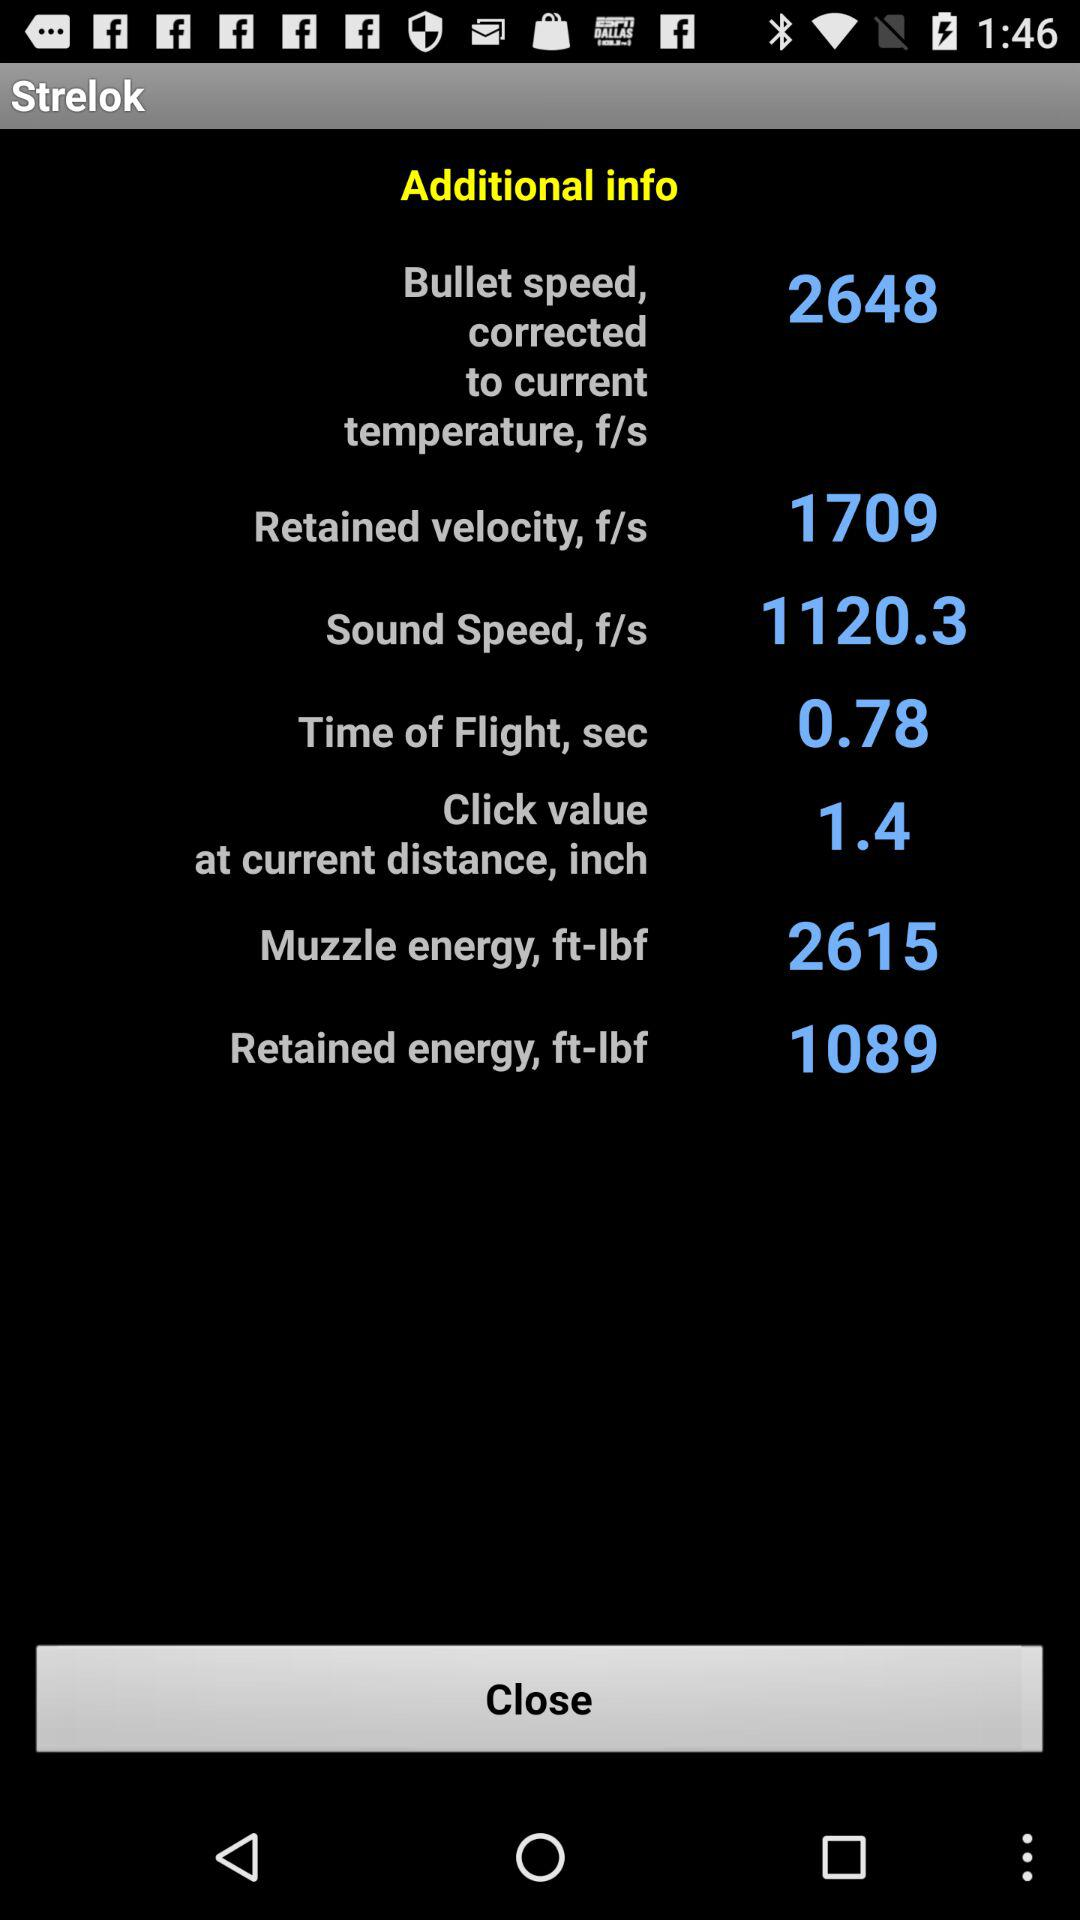What is the time of flight for a bullet traveling at 2648 f/s?
Answer the question using a single word or phrase. 0.78 